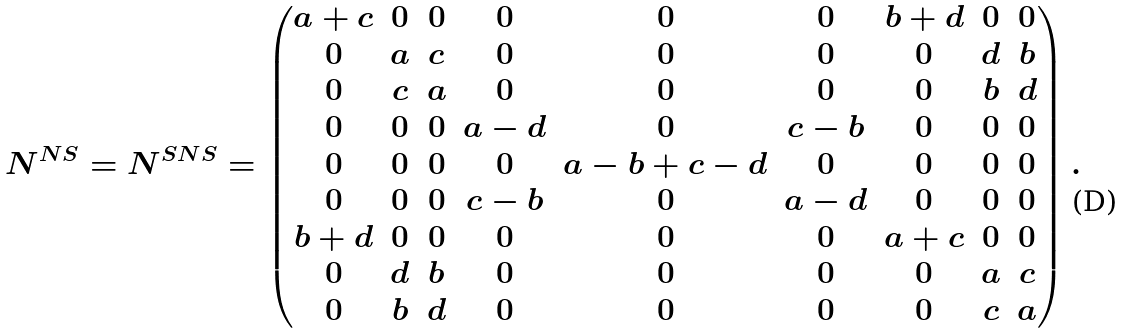Convert formula to latex. <formula><loc_0><loc_0><loc_500><loc_500>N ^ { N S } = N ^ { S N S } = \begin{pmatrix} a + c & 0 & 0 & 0 & 0 & 0 & b + d & 0 & 0 \\ 0 & a & c & 0 & 0 & 0 & 0 & d & b \\ 0 & c & a & 0 & 0 & 0 & 0 & b & d \\ 0 & 0 & 0 & a - d & 0 & c - b & 0 & 0 & 0 \\ 0 & 0 & 0 & 0 & a - b + c - d & 0 & 0 & 0 & 0 \\ 0 & 0 & 0 & c - b & 0 & a - d & 0 & 0 & 0 \\ b + d & 0 & 0 & 0 & 0 & 0 & a + c & 0 & 0 \\ 0 & d & b & 0 & 0 & 0 & 0 & a & c \\ 0 & b & d & 0 & 0 & 0 & 0 & c & a \end{pmatrix} .</formula> 